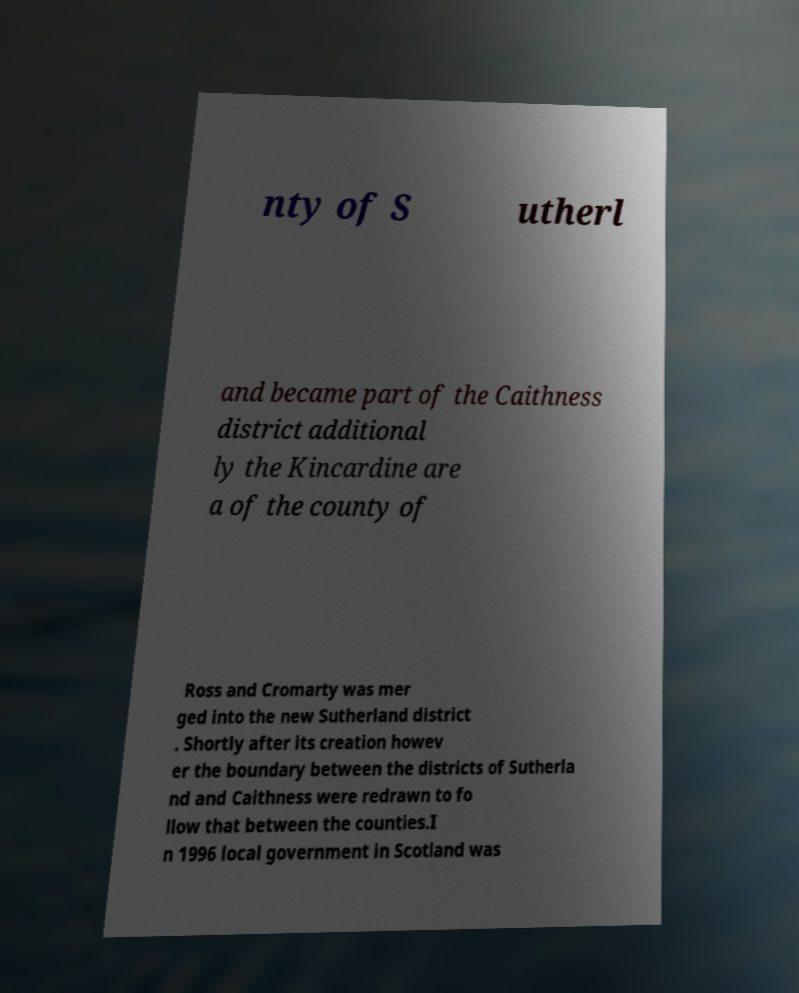There's text embedded in this image that I need extracted. Can you transcribe it verbatim? nty of S utherl and became part of the Caithness district additional ly the Kincardine are a of the county of Ross and Cromarty was mer ged into the new Sutherland district . Shortly after its creation howev er the boundary between the districts of Sutherla nd and Caithness were redrawn to fo llow that between the counties.I n 1996 local government in Scotland was 